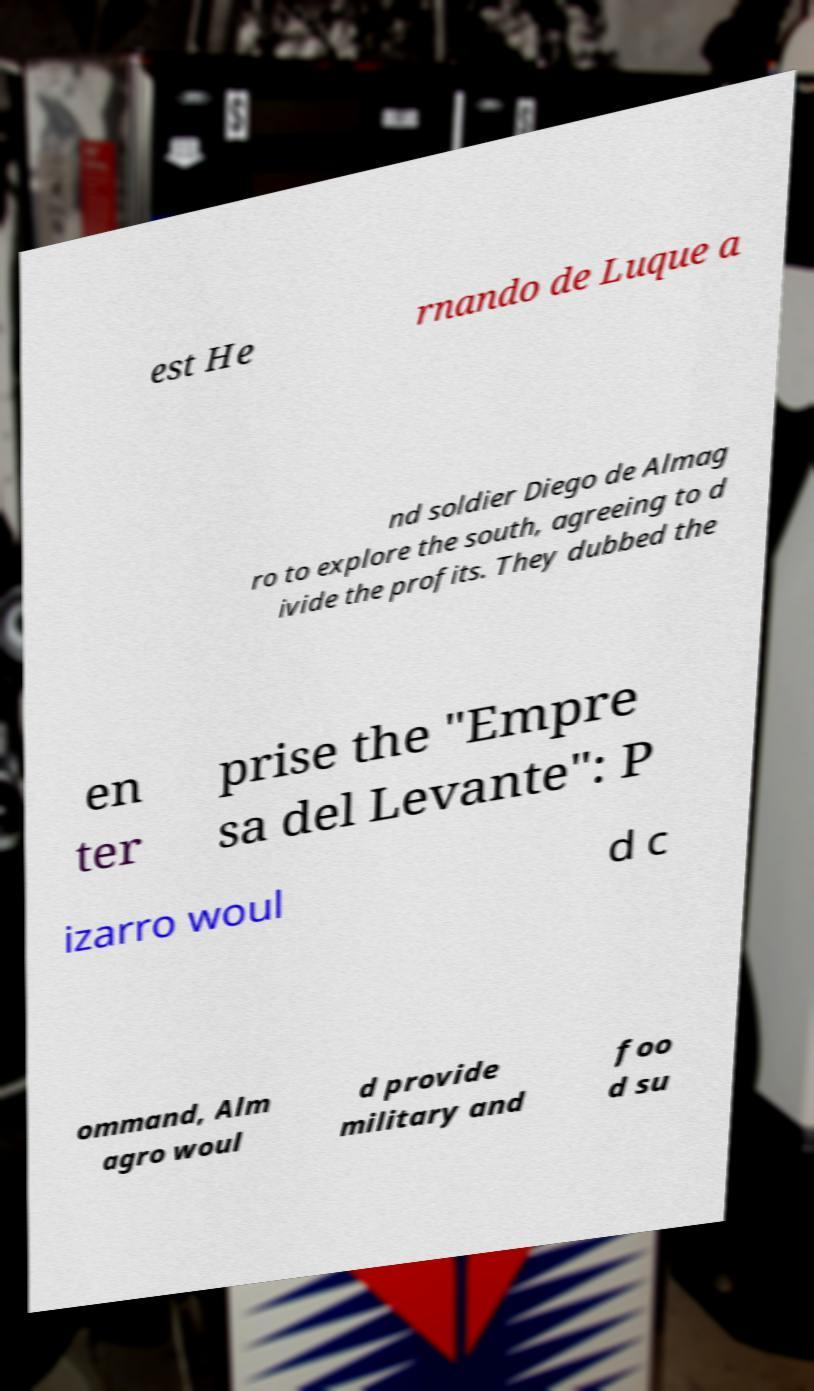There's text embedded in this image that I need extracted. Can you transcribe it verbatim? est He rnando de Luque a nd soldier Diego de Almag ro to explore the south, agreeing to d ivide the profits. They dubbed the en ter prise the "Empre sa del Levante": P izarro woul d c ommand, Alm agro woul d provide military and foo d su 